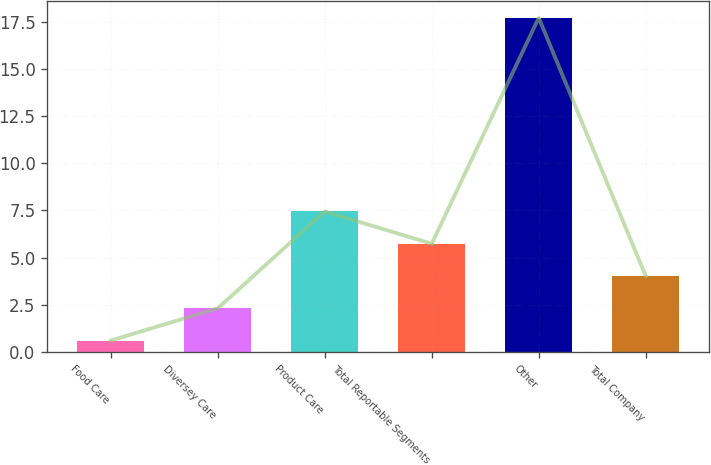Convert chart. <chart><loc_0><loc_0><loc_500><loc_500><bar_chart><fcel>Food Care<fcel>Diversey Care<fcel>Product Care<fcel>Total Reportable Segments<fcel>Other<fcel>Total Company<nl><fcel>0.6<fcel>2.31<fcel>7.44<fcel>5.73<fcel>17.7<fcel>4.02<nl></chart> 